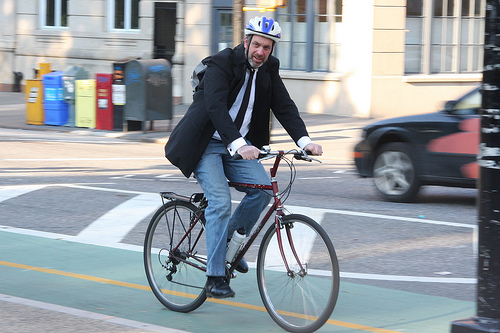<image>
Can you confirm if the man is behind the bike? No. The man is not behind the bike. From this viewpoint, the man appears to be positioned elsewhere in the scene. Where is the man in relation to the bike? Is it to the left of the bike? No. The man is not to the left of the bike. From this viewpoint, they have a different horizontal relationship. 